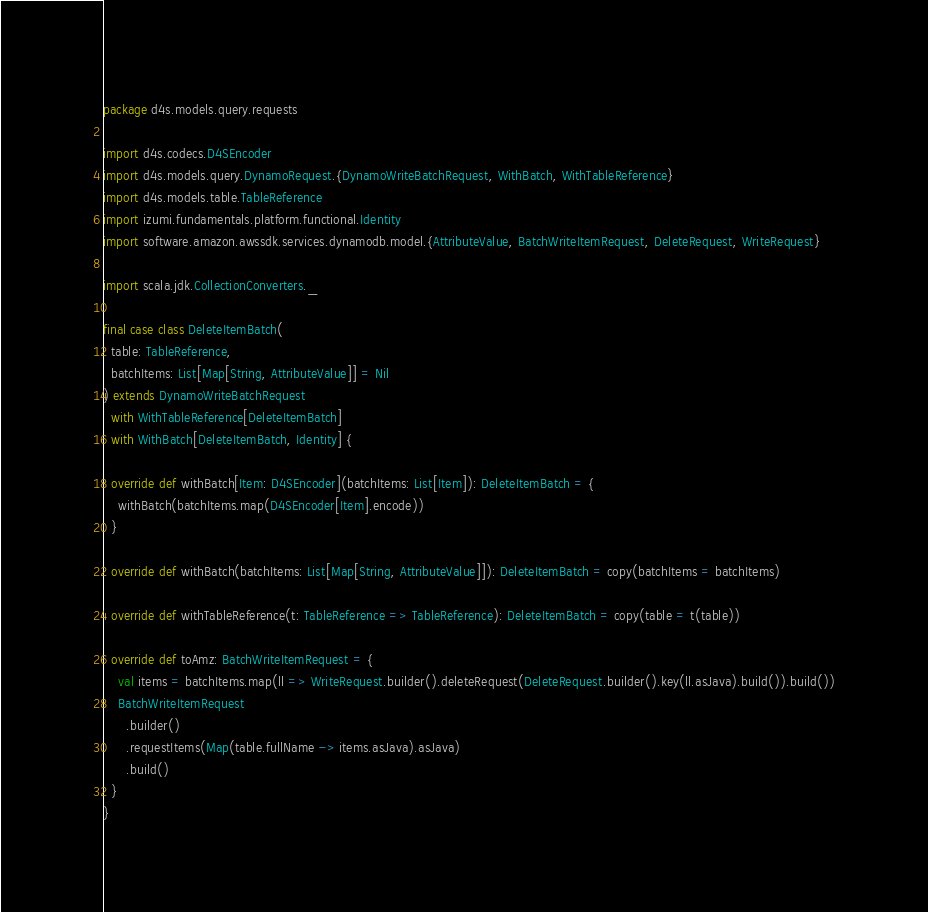Convert code to text. <code><loc_0><loc_0><loc_500><loc_500><_Scala_>package d4s.models.query.requests

import d4s.codecs.D4SEncoder
import d4s.models.query.DynamoRequest.{DynamoWriteBatchRequest, WithBatch, WithTableReference}
import d4s.models.table.TableReference
import izumi.fundamentals.platform.functional.Identity
import software.amazon.awssdk.services.dynamodb.model.{AttributeValue, BatchWriteItemRequest, DeleteRequest, WriteRequest}

import scala.jdk.CollectionConverters._

final case class DeleteItemBatch(
  table: TableReference,
  batchItems: List[Map[String, AttributeValue]] = Nil
) extends DynamoWriteBatchRequest
  with WithTableReference[DeleteItemBatch]
  with WithBatch[DeleteItemBatch, Identity] {

  override def withBatch[Item: D4SEncoder](batchItems: List[Item]): DeleteItemBatch = {
    withBatch(batchItems.map(D4SEncoder[Item].encode))
  }

  override def withBatch(batchItems: List[Map[String, AttributeValue]]): DeleteItemBatch = copy(batchItems = batchItems)

  override def withTableReference(t: TableReference => TableReference): DeleteItemBatch = copy(table = t(table))

  override def toAmz: BatchWriteItemRequest = {
    val items = batchItems.map(ll => WriteRequest.builder().deleteRequest(DeleteRequest.builder().key(ll.asJava).build()).build())
    BatchWriteItemRequest
      .builder()
      .requestItems(Map(table.fullName -> items.asJava).asJava)
      .build()
  }
}
</code> 